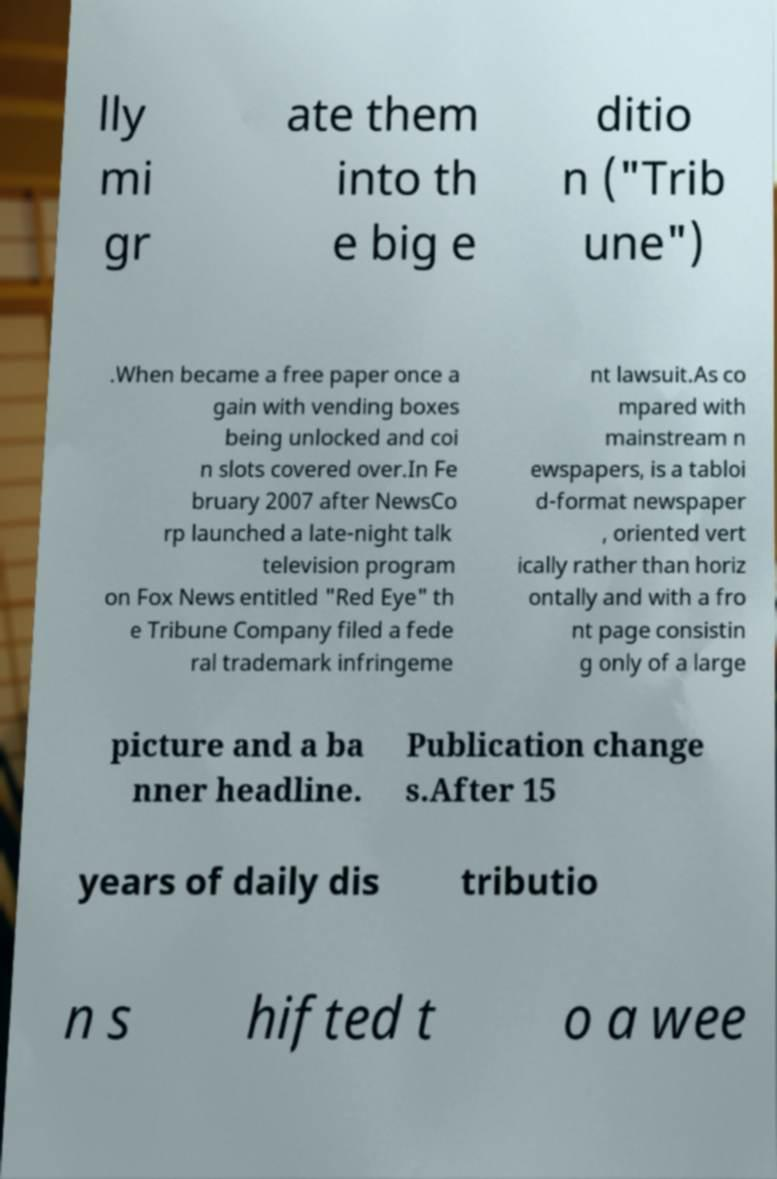Can you accurately transcribe the text from the provided image for me? lly mi gr ate them into th e big e ditio n ("Trib une") .When became a free paper once a gain with vending boxes being unlocked and coi n slots covered over.In Fe bruary 2007 after NewsCo rp launched a late-night talk television program on Fox News entitled "Red Eye" th e Tribune Company filed a fede ral trademark infringeme nt lawsuit.As co mpared with mainstream n ewspapers, is a tabloi d-format newspaper , oriented vert ically rather than horiz ontally and with a fro nt page consistin g only of a large picture and a ba nner headline. Publication change s.After 15 years of daily dis tributio n s hifted t o a wee 